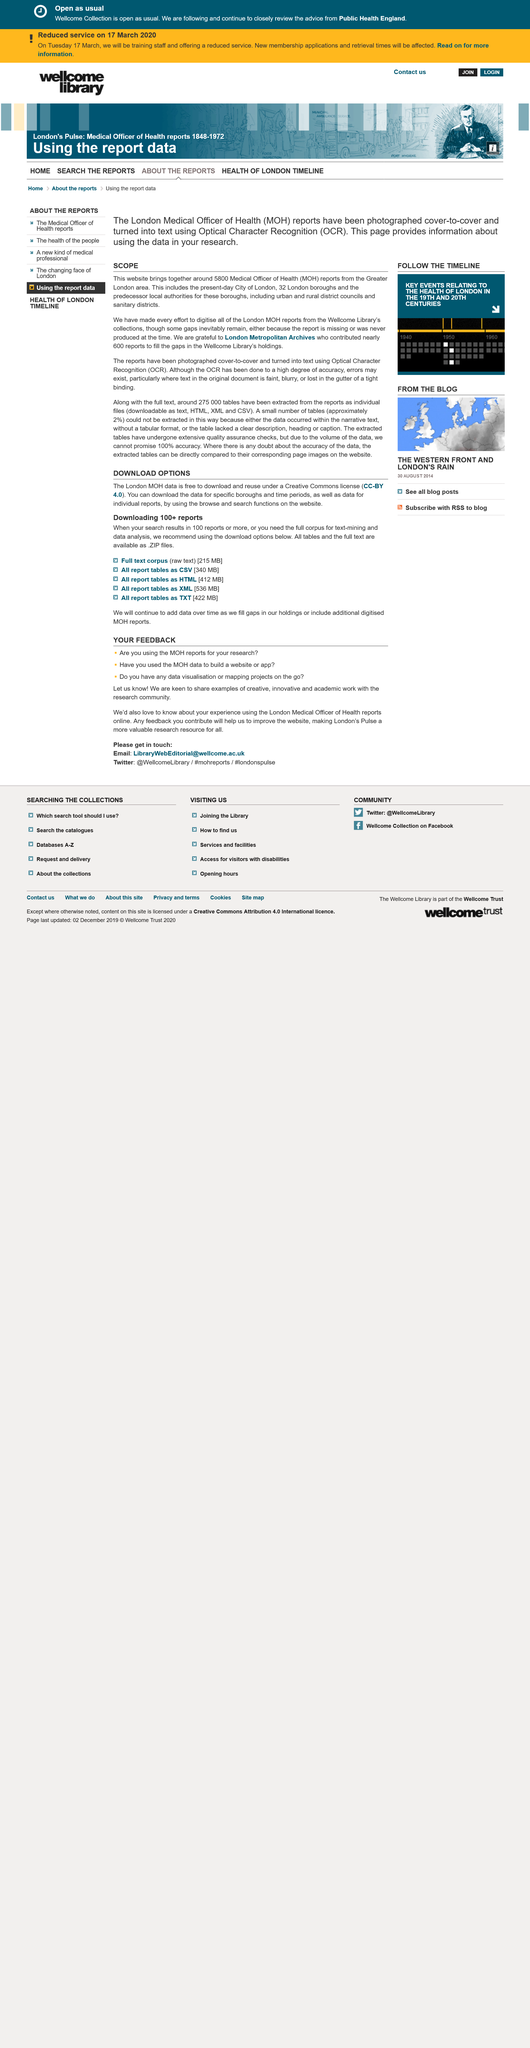Outline some significant characteristics in this image. The London Metropolitan Archives contributed 600 reports to fill the gaps in the Wellcome Library's holdings. Medical Officer of Health" is an official position in the public health sector that is responsible for ensuring the health and wellbeing of a community by providing medical advice and guidance to local governments. This page is about the topic of downloads, which involves the process of obtaining digital content from the internet. Yes, the London MOH data is available for free download. Yes, the tables and full text are available as ZIP files. 